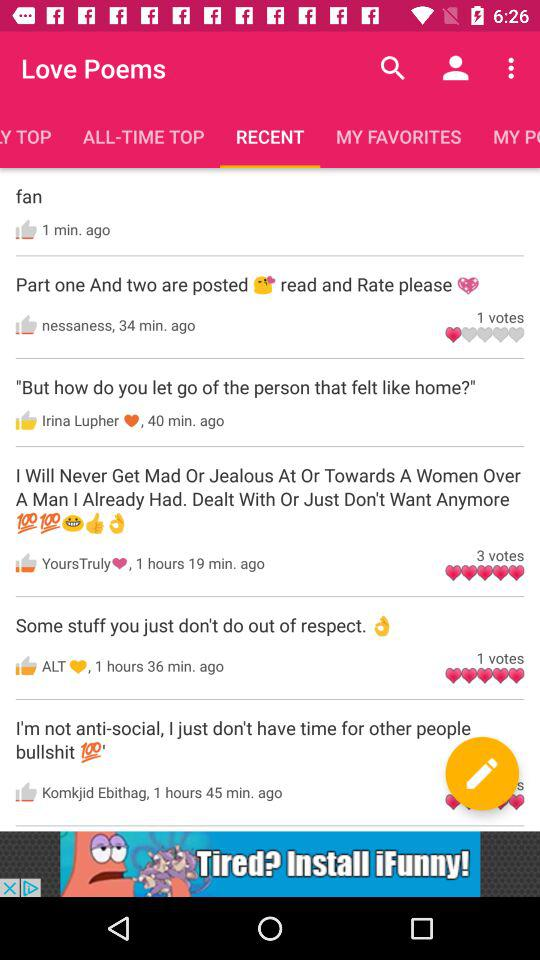What is the selected tab? The selected tab is "RECENT". 